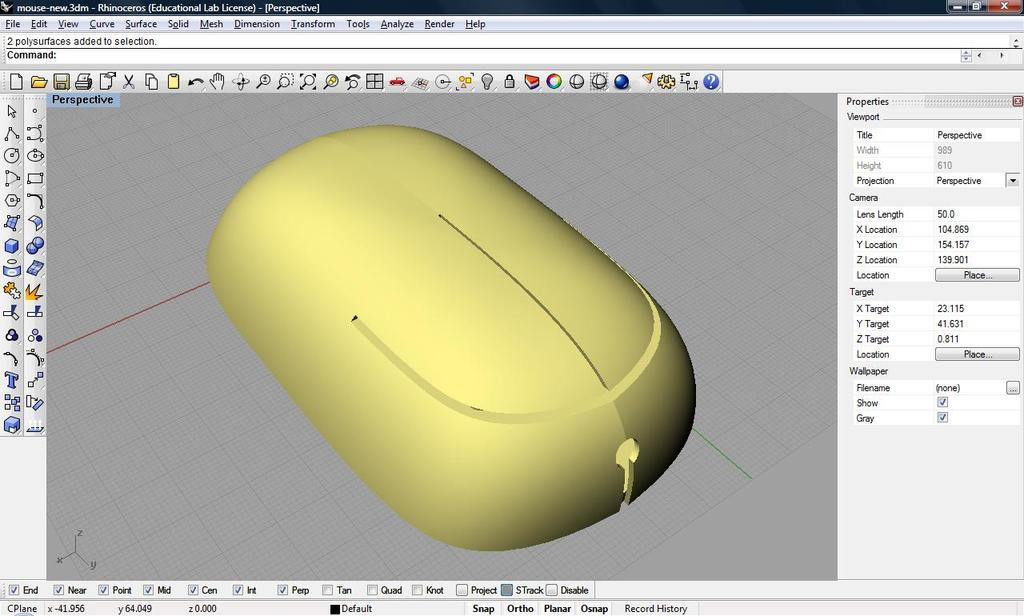What is the main subject of the image? The main subject of the image is a screenshot of a painting page. What is being drawn in the center of the image? There is a yellow color mouse drawing in the center of the image. What can be seen on the sides of the image? There is an icon bar visible in the image. What type of quill is being used to draw the mouse in the image? There is no quill present in the image; the drawing is being done using a digital mouse. How many tickets are visible in the image? There are no tickets present in the image; it is a screenshot of a painting page with a drawing of a yellow mouse and an icon bar. 